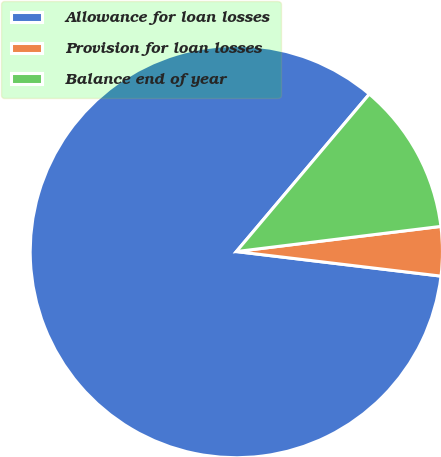Convert chart. <chart><loc_0><loc_0><loc_500><loc_500><pie_chart><fcel>Allowance for loan losses<fcel>Provision for loan losses<fcel>Balance end of year<nl><fcel>84.26%<fcel>3.85%<fcel>11.89%<nl></chart> 